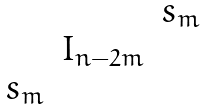<formula> <loc_0><loc_0><loc_500><loc_500>\begin{matrix} & & s _ { m } \\ & I _ { n - 2 m } & \\ s _ { m } & & \end{matrix}</formula> 